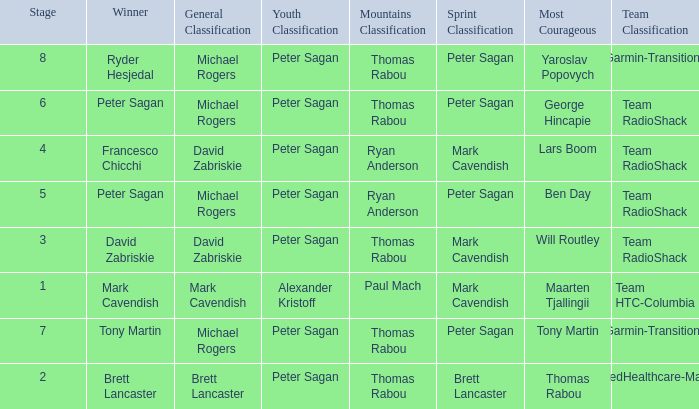When Peter Sagan won the youth classification and Thomas Rabou won the most corageous, who won the sprint classification? Brett Lancaster. 